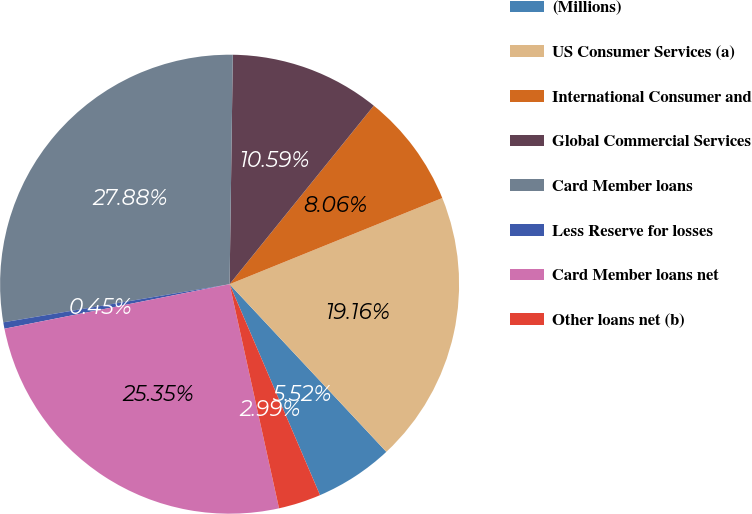Convert chart to OTSL. <chart><loc_0><loc_0><loc_500><loc_500><pie_chart><fcel>(Millions)<fcel>US Consumer Services (a)<fcel>International Consumer and<fcel>Global Commercial Services<fcel>Card Member loans<fcel>Less Reserve for losses<fcel>Card Member loans net<fcel>Other loans net (b)<nl><fcel>5.52%<fcel>19.16%<fcel>8.06%<fcel>10.59%<fcel>27.88%<fcel>0.45%<fcel>25.35%<fcel>2.99%<nl></chart> 